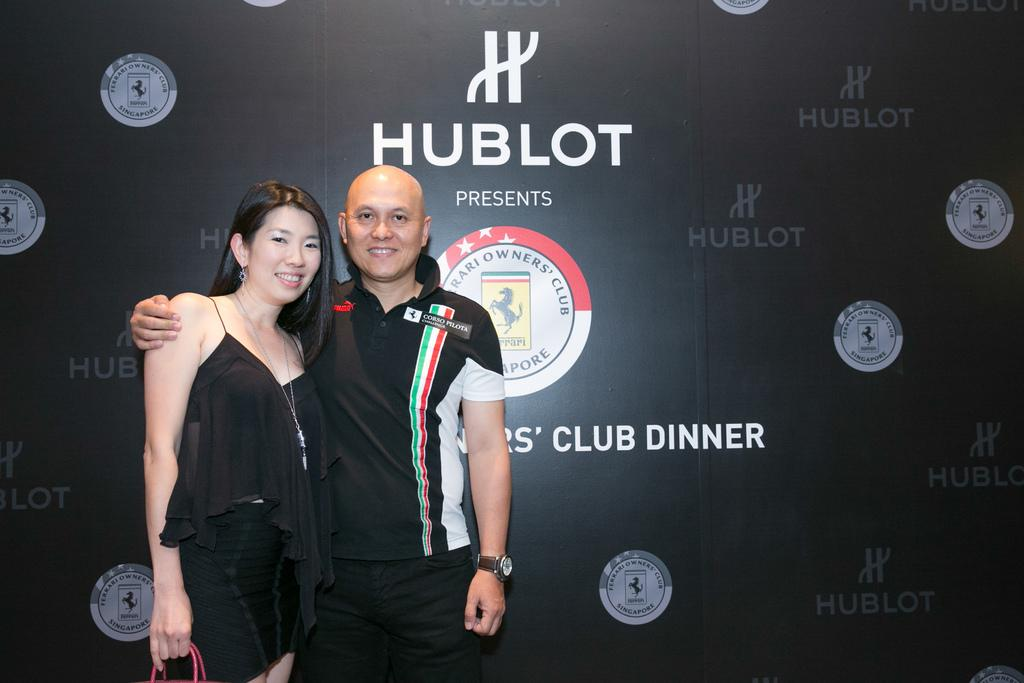<image>
Summarize the visual content of the image. Two people at the Ferrari Club Dinner presented by Hublot 